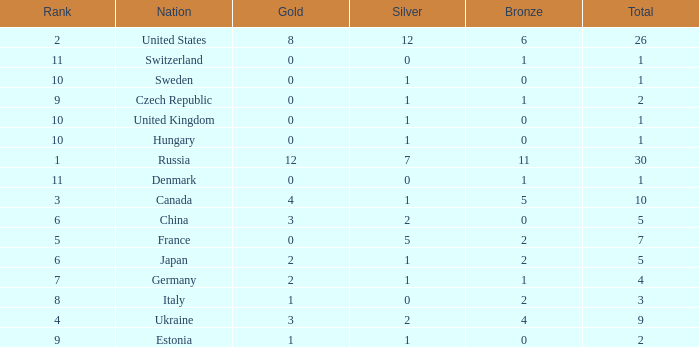Which silver has a Gold smaller than 12, a Rank smaller than 5, and a Bronze of 5? 1.0. 